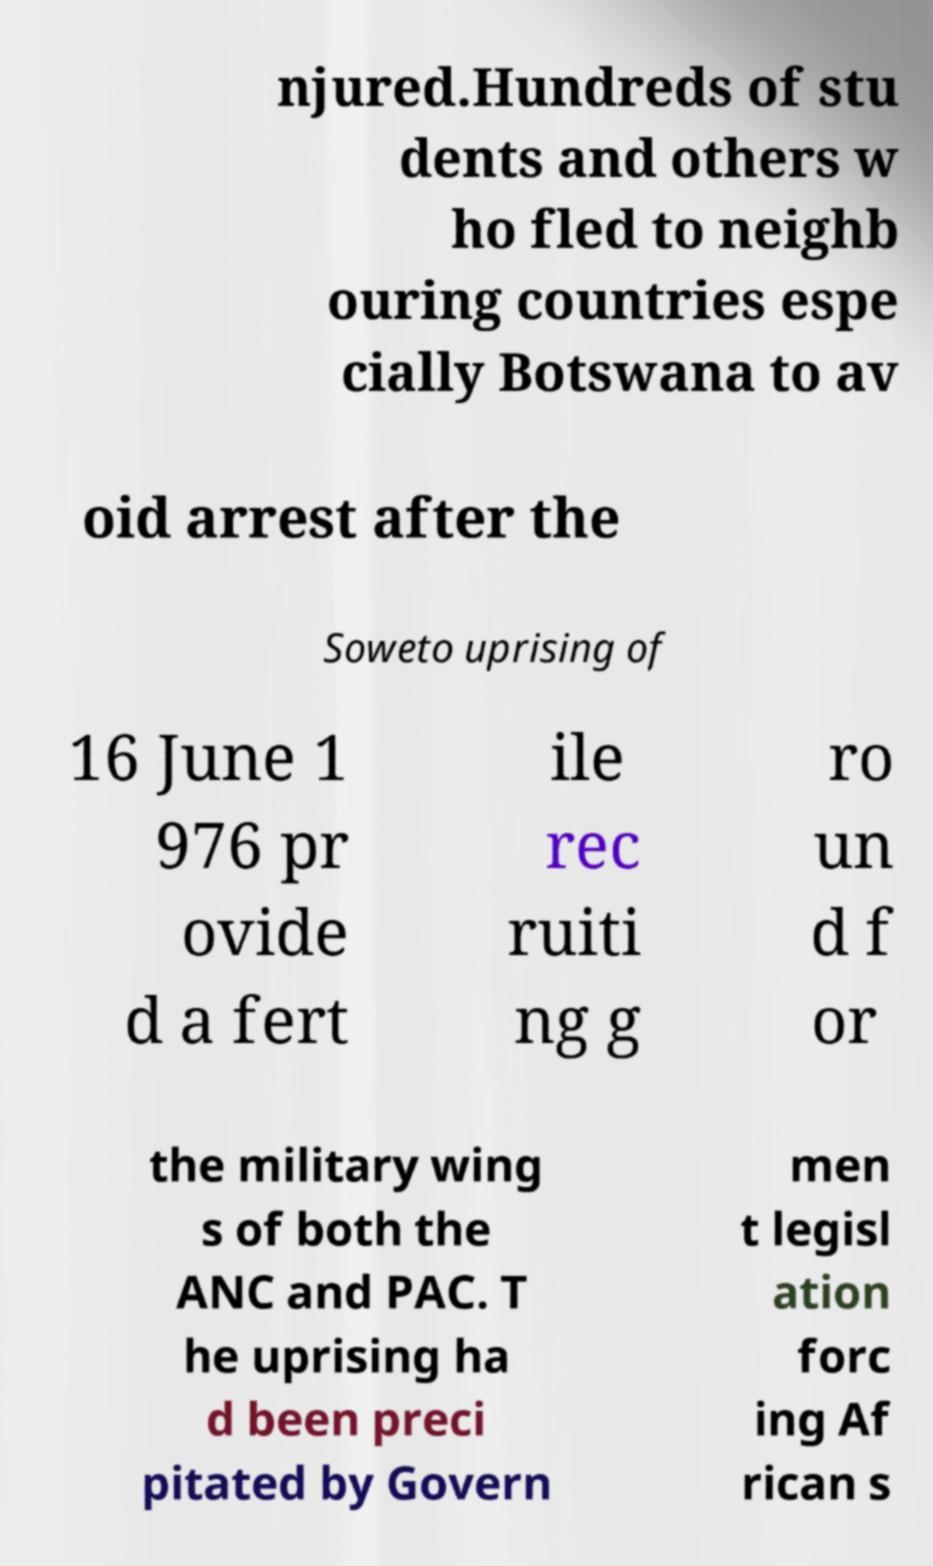Could you extract and type out the text from this image? njured.Hundreds of stu dents and others w ho fled to neighb ouring countries espe cially Botswana to av oid arrest after the Soweto uprising of 16 June 1 976 pr ovide d a fert ile rec ruiti ng g ro un d f or the military wing s of both the ANC and PAC. T he uprising ha d been preci pitated by Govern men t legisl ation forc ing Af rican s 